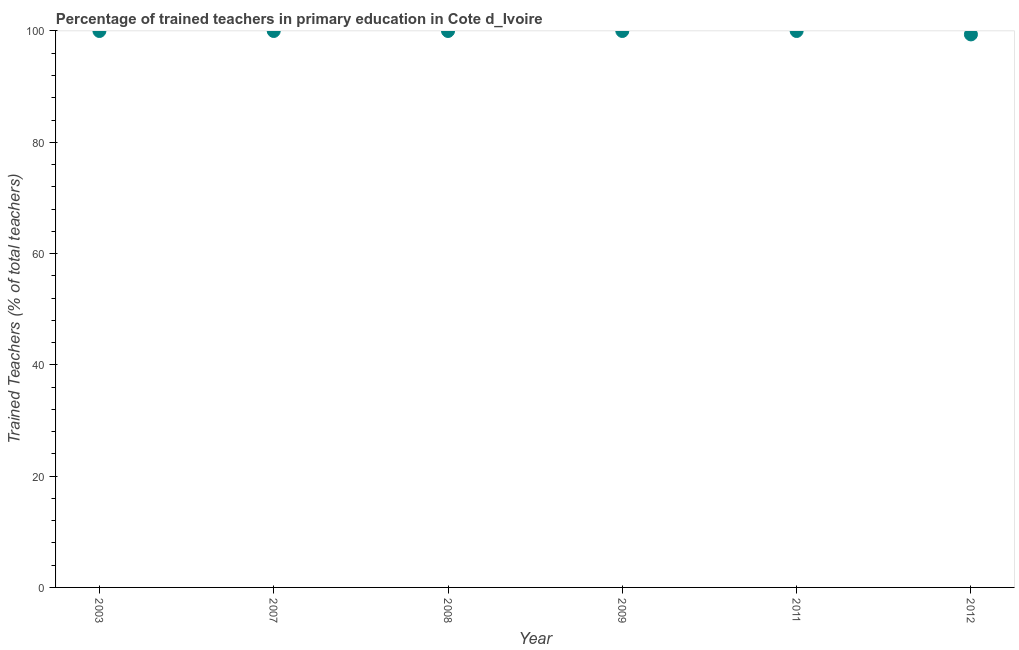What is the percentage of trained teachers in 2011?
Offer a terse response. 100. Across all years, what is the minimum percentage of trained teachers?
Make the answer very short. 99.38. What is the sum of the percentage of trained teachers?
Offer a very short reply. 599.38. What is the difference between the percentage of trained teachers in 2011 and 2012?
Keep it short and to the point. 0.62. What is the average percentage of trained teachers per year?
Make the answer very short. 99.9. In how many years, is the percentage of trained teachers greater than 68 %?
Your answer should be compact. 6. Do a majority of the years between 2003 and 2011 (inclusive) have percentage of trained teachers greater than 12 %?
Provide a short and direct response. Yes. Is the percentage of trained teachers in 2003 less than that in 2008?
Provide a short and direct response. No. Is the difference between the percentage of trained teachers in 2007 and 2012 greater than the difference between any two years?
Offer a very short reply. Yes. What is the difference between the highest and the second highest percentage of trained teachers?
Give a very brief answer. 0. What is the difference between the highest and the lowest percentage of trained teachers?
Ensure brevity in your answer.  0.62. In how many years, is the percentage of trained teachers greater than the average percentage of trained teachers taken over all years?
Your response must be concise. 5. How many years are there in the graph?
Provide a succinct answer. 6. Does the graph contain any zero values?
Offer a terse response. No. What is the title of the graph?
Your answer should be very brief. Percentage of trained teachers in primary education in Cote d_Ivoire. What is the label or title of the Y-axis?
Provide a succinct answer. Trained Teachers (% of total teachers). What is the Trained Teachers (% of total teachers) in 2003?
Keep it short and to the point. 100. What is the Trained Teachers (% of total teachers) in 2012?
Make the answer very short. 99.38. What is the difference between the Trained Teachers (% of total teachers) in 2003 and 2007?
Provide a succinct answer. 0. What is the difference between the Trained Teachers (% of total teachers) in 2003 and 2008?
Your answer should be compact. 0. What is the difference between the Trained Teachers (% of total teachers) in 2003 and 2011?
Provide a short and direct response. 0. What is the difference between the Trained Teachers (% of total teachers) in 2003 and 2012?
Offer a terse response. 0.62. What is the difference between the Trained Teachers (% of total teachers) in 2007 and 2008?
Give a very brief answer. 0. What is the difference between the Trained Teachers (% of total teachers) in 2007 and 2009?
Your answer should be compact. 0. What is the difference between the Trained Teachers (% of total teachers) in 2007 and 2012?
Ensure brevity in your answer.  0.62. What is the difference between the Trained Teachers (% of total teachers) in 2008 and 2009?
Keep it short and to the point. 0. What is the difference between the Trained Teachers (% of total teachers) in 2008 and 2011?
Provide a short and direct response. 0. What is the difference between the Trained Teachers (% of total teachers) in 2008 and 2012?
Make the answer very short. 0.62. What is the difference between the Trained Teachers (% of total teachers) in 2009 and 2011?
Offer a terse response. 0. What is the difference between the Trained Teachers (% of total teachers) in 2009 and 2012?
Offer a very short reply. 0.62. What is the difference between the Trained Teachers (% of total teachers) in 2011 and 2012?
Ensure brevity in your answer.  0.62. What is the ratio of the Trained Teachers (% of total teachers) in 2003 to that in 2011?
Your response must be concise. 1. What is the ratio of the Trained Teachers (% of total teachers) in 2003 to that in 2012?
Offer a very short reply. 1.01. What is the ratio of the Trained Teachers (% of total teachers) in 2007 to that in 2011?
Your response must be concise. 1. What is the ratio of the Trained Teachers (% of total teachers) in 2008 to that in 2009?
Keep it short and to the point. 1. What is the ratio of the Trained Teachers (% of total teachers) in 2008 to that in 2011?
Provide a succinct answer. 1. What is the ratio of the Trained Teachers (% of total teachers) in 2009 to that in 2012?
Ensure brevity in your answer.  1.01. What is the ratio of the Trained Teachers (% of total teachers) in 2011 to that in 2012?
Your answer should be very brief. 1.01. 